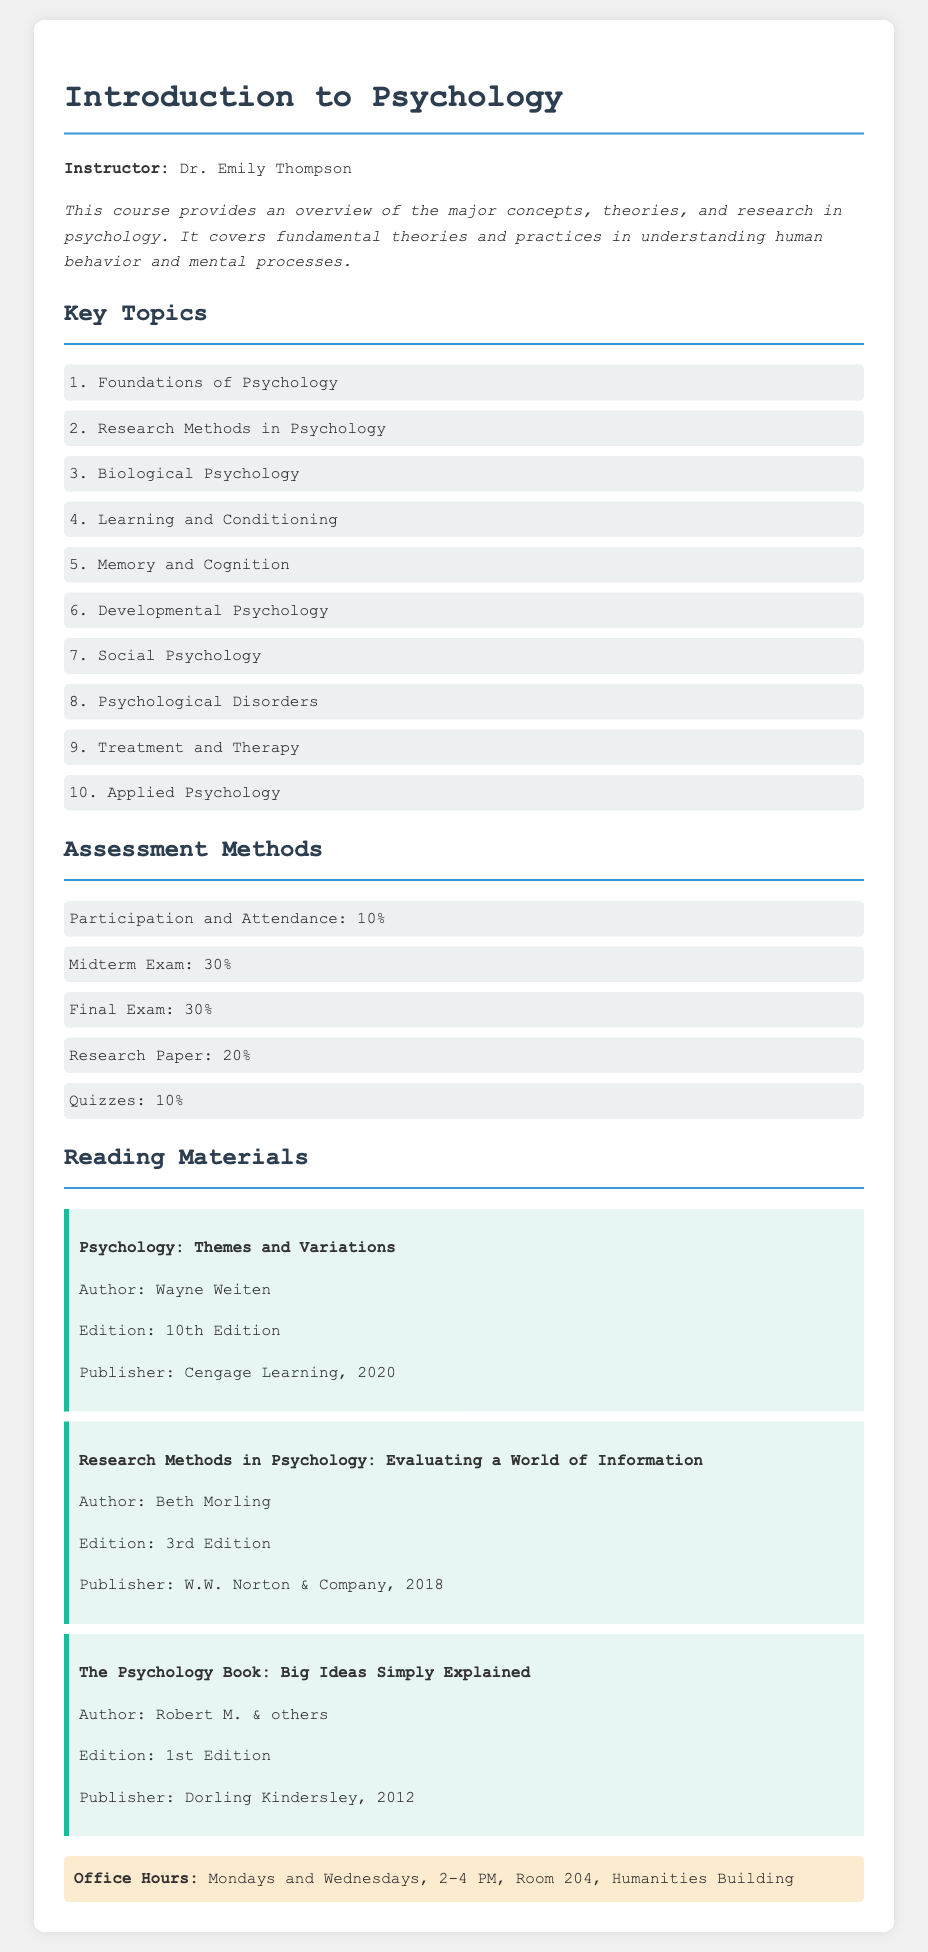What is the instructor's name? The instructor's name is mentioned at the beginning of the document, which states "Instructor: Dr. Emily Thompson."
Answer: Dr. Emily Thompson How many key topics are listed in the syllabus? The document lists a total of ten key topics under the "Key Topics" section.
Answer: 10 What percentage does the midterm exam contribute to the overall assessment? The document states that the midterm exam is worth 30% of the total assessment.
Answer: 30% What is the title of the first reading material? The document lists "Psychology: Themes and Variations" as the first reading material.
Answer: Psychology: Themes and Variations When are the instructor's office hours? The document specifies that office hours are on Mondays and Wednesdays, 2-4 PM.
Answer: Mondays and Wednesdays, 2-4 PM Which publisher released the book "Research Methods in Psychology"? The document indicates that "Research Methods in Psychology" was published by W.W. Norton & Company.
Answer: W.W. Norton & Company What is the weight of the participation and attendance component in the assessment? The assessment methods specify that participation and attendance contribute 10% to the overall grade.
Answer: 10% Which topic is listed last in the key topics section? The last topic in the "Key Topics" section is "Applied Psychology."
Answer: Applied Psychology 